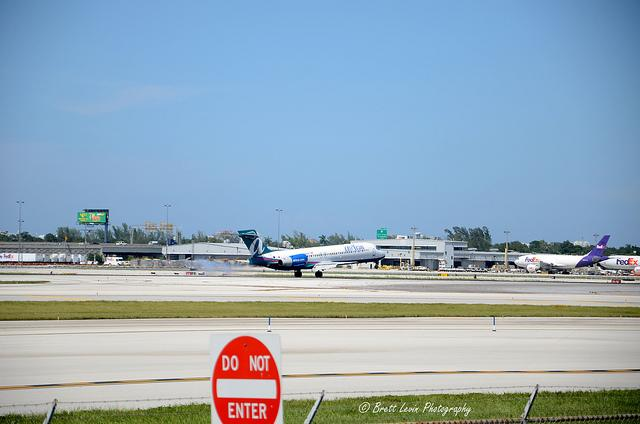What color is the FedEx airplane's tail fin? blue 